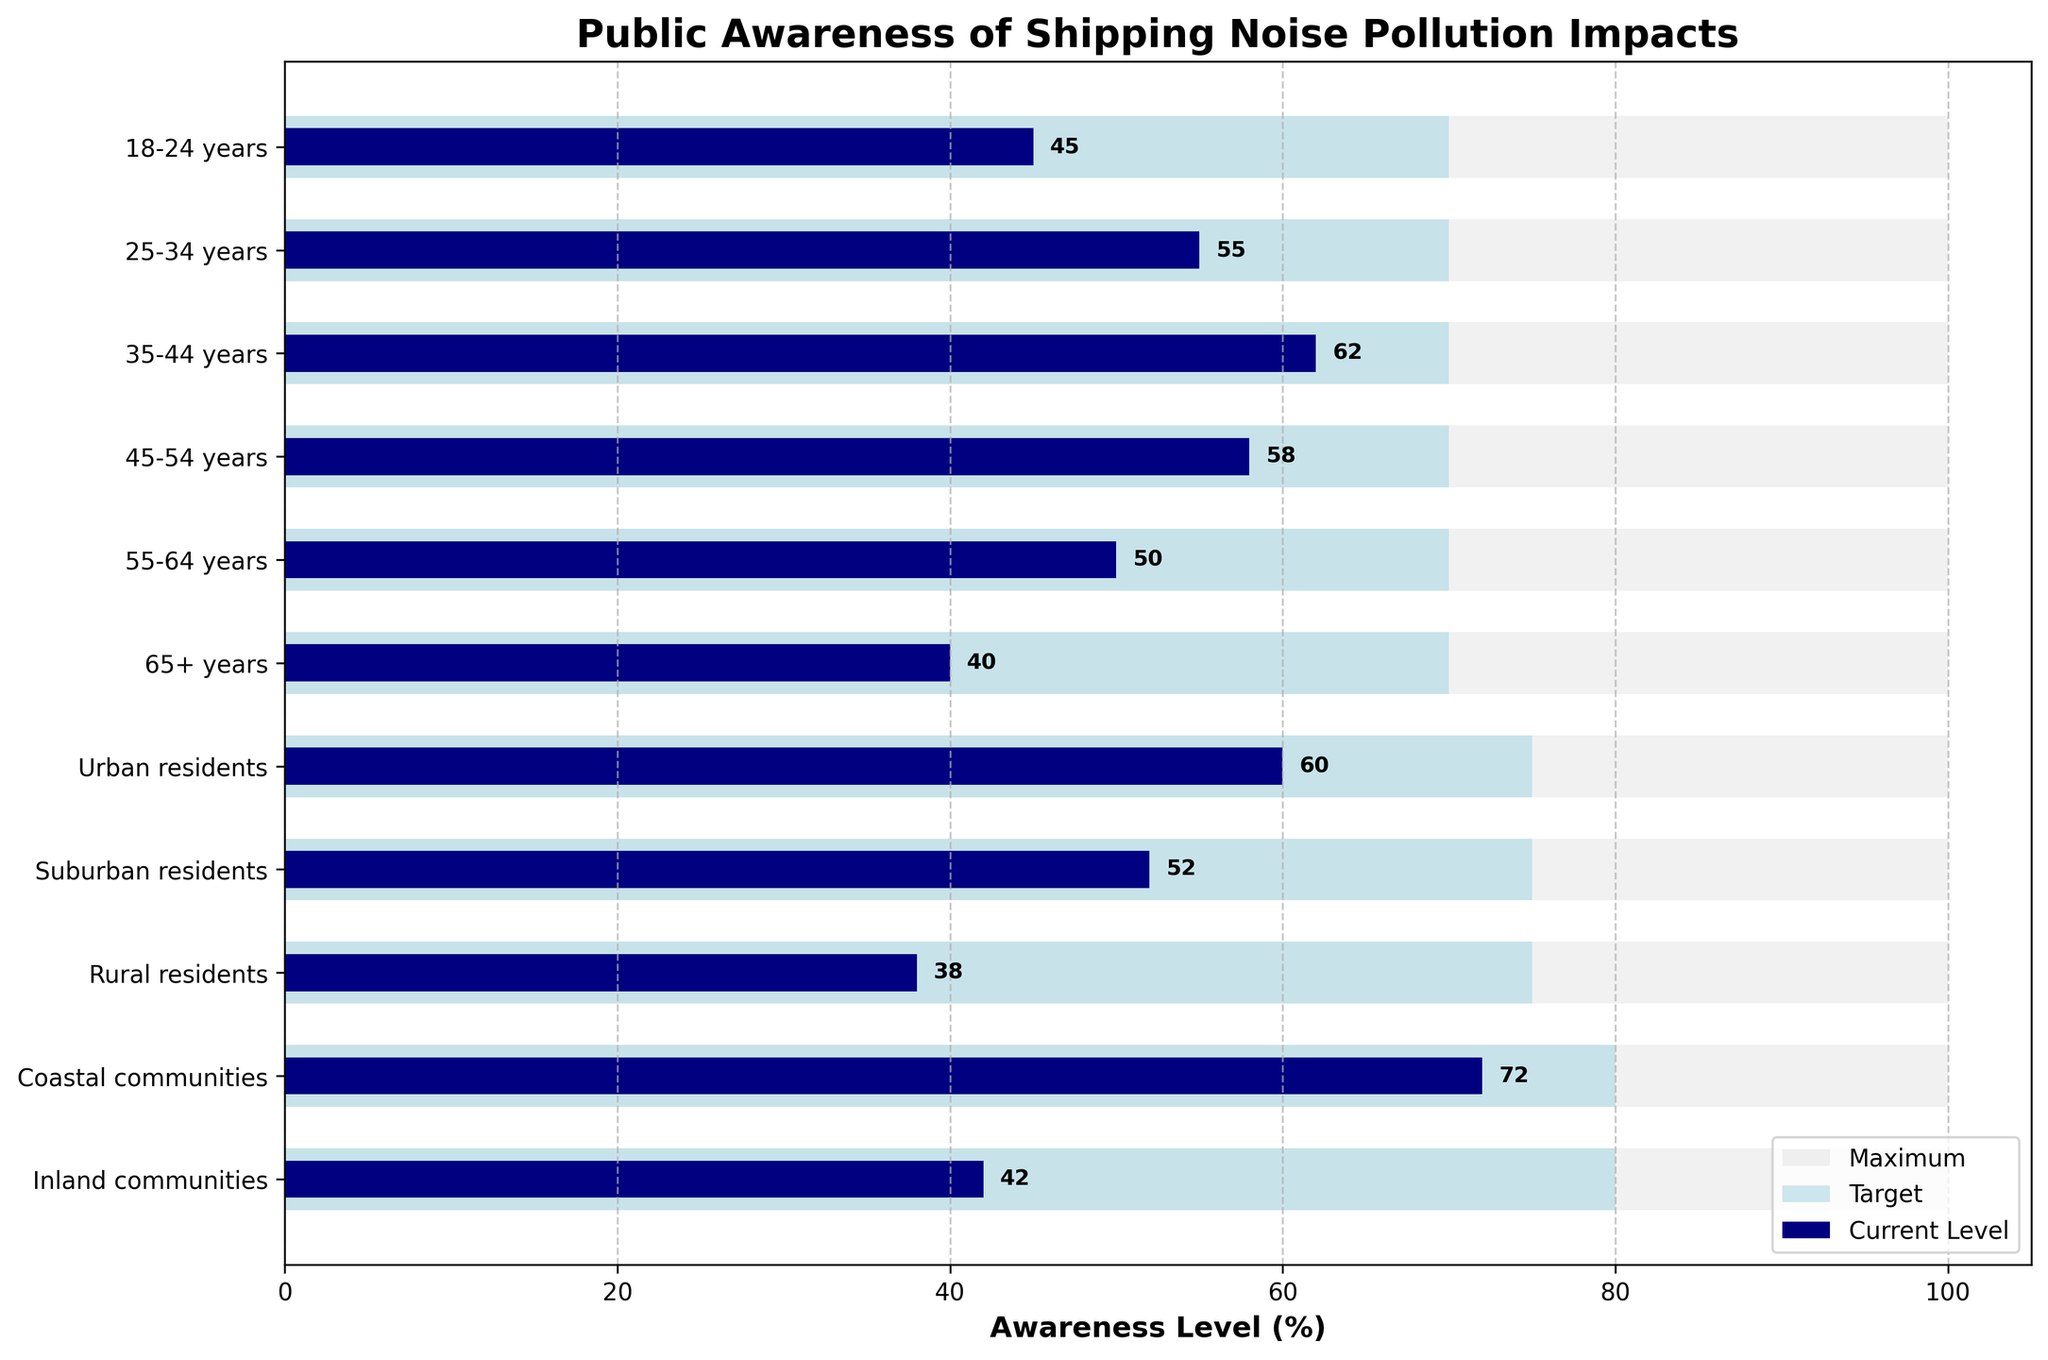What is the title of the chart? The title is located at the top of the chart. It reads "Public Awareness of Shipping Noise Pollution Impacts."
Answer: Public Awareness of Shipping Noise Pollution Impacts What demographic has the highest current awareness level? The highest bar representing 'Current Level' in navy color reaches 72% for the “Coastal communities” demographic.
Answer: Coastal communities What is the awareness level for the 55-64 years demographic? The navy bar for the 55-64 years demographic indicates an awareness level of 50%.
Answer: 50% Which demographic group has the lowest awareness level? The lowest navy bar, representing the 'Current Level,' is 38% for the "Rural residents" demographic.
Answer: Rural residents What is the difference between the awareness level and the target for Urban residents? The navy-colored 'Current Level' for Urban residents is 60%, and the light blue-colored 'Target' level is 75%. The difference is 75% - 60% = 15%.
Answer: 15% How many demographic groups have a current awareness level above 50%? By examining the navy bars: 25-34 years (55%), 35-44 years (62%), 45-54 years (58%), Urban residents (60%), and Coastal communities (72%) all have levels above 50%. That’s a total of 5 groups.
Answer: 5 What is the range of awareness levels among inland communities and coastal communities? The 'Current Level' for Inland communities is 42%, and for Coastal communities, it is 72%. The range is 72% - 42% = 30%.
Answer: 30% How does the awareness level of the 18-24 years demographic compare to the 65+ years demographic? 18-24 years shows an awareness level of 45%, while 65+ years shows 40%. 45% is higher than 40% by 5%.
Answer: 5% What is the average awareness level of all the demographic groups? Sum the awareness levels and divide by the number of groups: (45 + 55 + 62 + 58 + 50 + 40 + 60 + 52 + 38 + 72 + 42) / 11 = 574 / 11 ≈ 52.18%.
Answer: 52.18% What is the difference between the maximum awareness level and the target for coastal communities? For Coastal communities, the maximum is 100% and the target is 80%. The difference is 100% - 80% = 20%.
Answer: 20% 